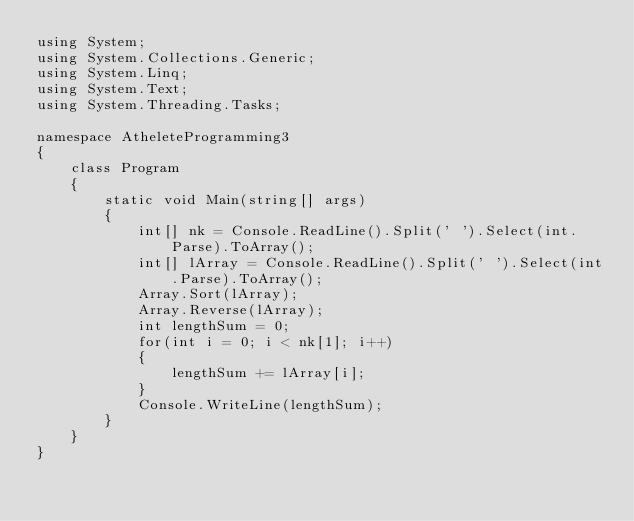Convert code to text. <code><loc_0><loc_0><loc_500><loc_500><_C#_>using System;
using System.Collections.Generic;
using System.Linq;
using System.Text;
using System.Threading.Tasks;

namespace AtheleteProgramming3
{
    class Program
    {
        static void Main(string[] args)
        {
            int[] nk = Console.ReadLine().Split(' ').Select(int.Parse).ToArray();
            int[] lArray = Console.ReadLine().Split(' ').Select(int.Parse).ToArray();
            Array.Sort(lArray);
            Array.Reverse(lArray);
            int lengthSum = 0;
            for(int i = 0; i < nk[1]; i++)
            {
                lengthSum += lArray[i];
            }
            Console.WriteLine(lengthSum);
        }
    }
}
</code> 